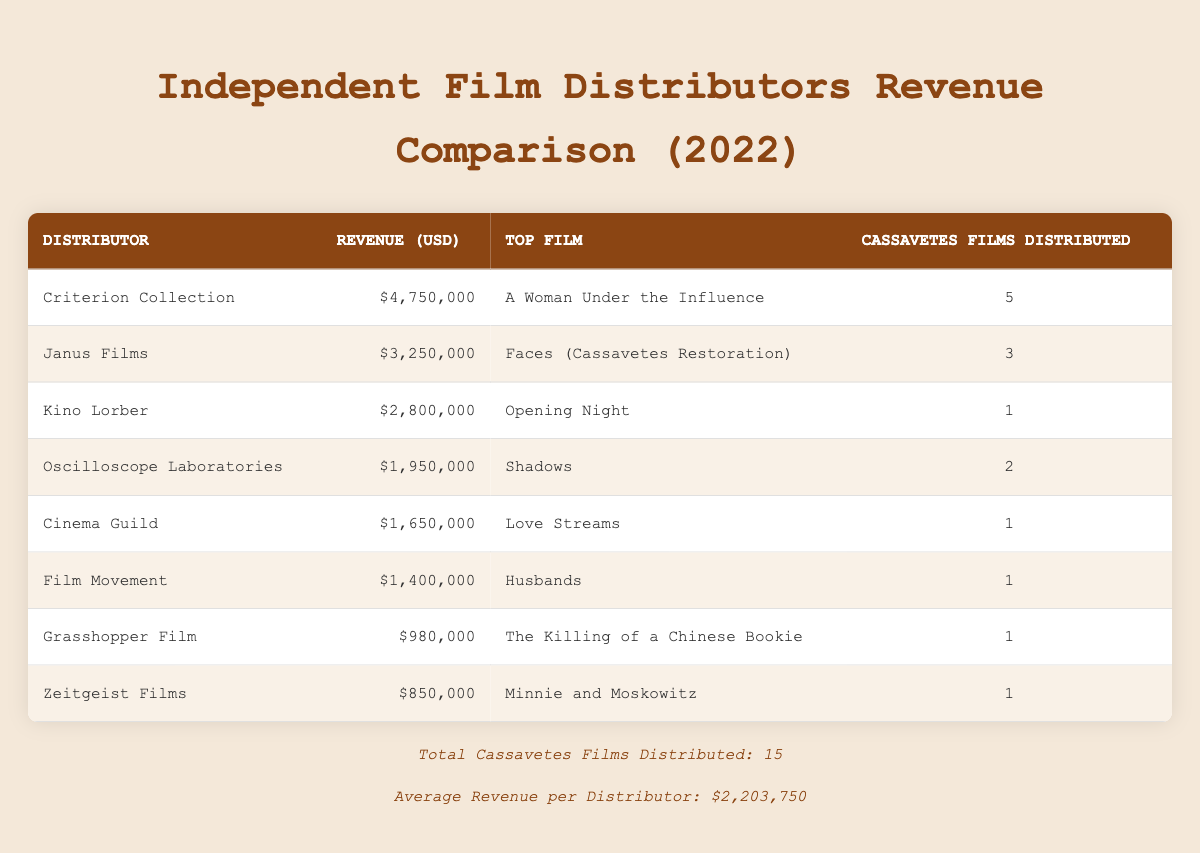What was the revenue for Criterion Collection? The table displays the revenue for each distributor. For Criterion Collection, the revenue is listed as $4,750,000.
Answer: $4,750,000 Which distributor had the highest revenue? By comparing the revenue figures across all distributors, Criterion Collection has the highest revenue at $4,750,000.
Answer: Criterion Collection How many Cassavetes films did Janus Films distribute? The table indicates that Janus Films distributed 3 Cassavetes films, which is directly stated in the corresponding row.
Answer: 3 What is the average revenue for the distributors listed? The footer of the table states that the average revenue per distributor is $2,203,750, providing the exact average calculated across all distributors.
Answer: $2,203,750 Is it true that Kino Lorber distributed more Cassavetes films than Oscilloscope Laboratories? The table shows that Kino Lorber distributed 1 Cassavetes film and Oscilloscope Laboratories distributed 2. This indicates that Kino Lorber did not distribute more films than Oscilloscope Laboratories, making the statement false.
Answer: No Which distributor had the lowest revenue? By examining all revenue figures in the table, Grasshopper Film has the lowest revenue listed, which is $980,000.
Answer: Grasshopper Film If you combine the revenues of Film Movement and Cinema Guild, what is the total? Film Movement's revenue is $1,400,000 and Cinema Guild's is $1,650,000. Combining them gives a total of $1,400,000 + $1,650,000 = $3,050,000.
Answer: $3,050,000 What percentage of the total Cassavetes films distributed does the Criterion Collection account for? There are a total of 15 Cassavetes films distributed. Criterion Collection distributed 5 of those. To find the percentage, divide 5 by 15 and multiply by 100: (5/15) * 100 = 33.33%.
Answer: 33.33% 